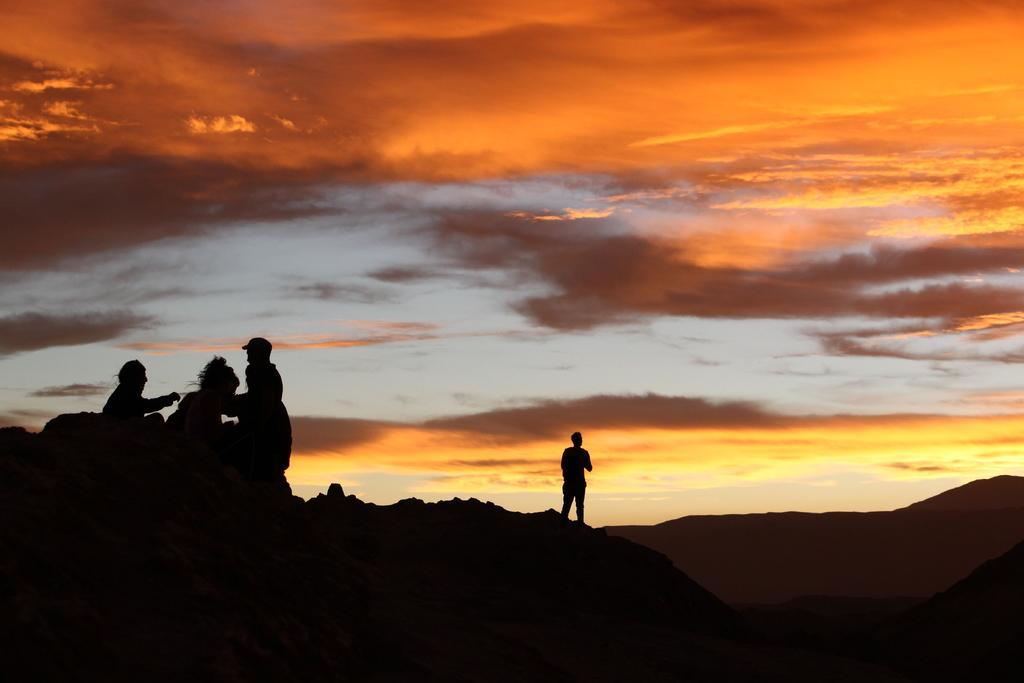Please provide a concise description of this image. In this picture there is a man who is standing on the mountain. On the left there are three persons were sitting on the stone. At the top we can see the sky and clouds. 